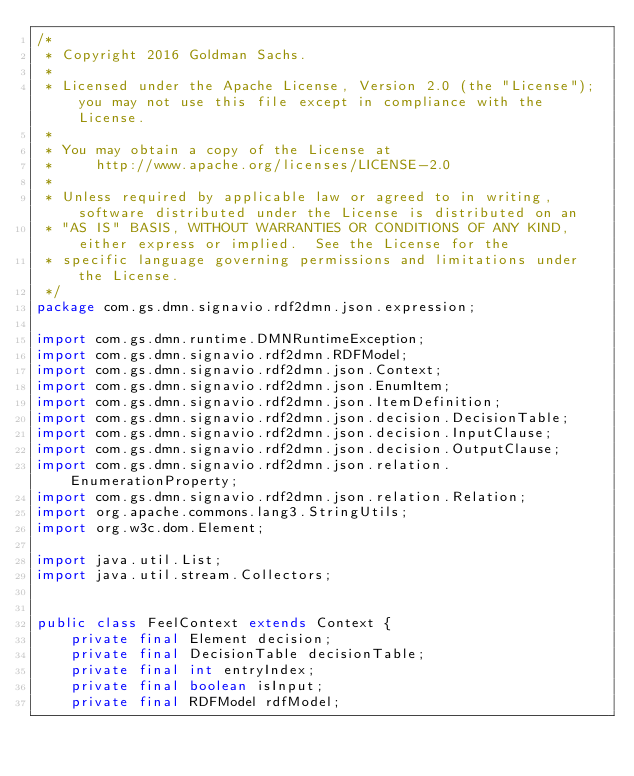Convert code to text. <code><loc_0><loc_0><loc_500><loc_500><_Java_>/*
 * Copyright 2016 Goldman Sachs.
 *
 * Licensed under the Apache License, Version 2.0 (the "License"); you may not use this file except in compliance with the License.
 *
 * You may obtain a copy of the License at
 *     http://www.apache.org/licenses/LICENSE-2.0
 *
 * Unless required by applicable law or agreed to in writing, software distributed under the License is distributed on an
 * "AS IS" BASIS, WITHOUT WARRANTIES OR CONDITIONS OF ANY KIND, either express or implied.  See the License for the
 * specific language governing permissions and limitations under the License.
 */
package com.gs.dmn.signavio.rdf2dmn.json.expression;

import com.gs.dmn.runtime.DMNRuntimeException;
import com.gs.dmn.signavio.rdf2dmn.RDFModel;
import com.gs.dmn.signavio.rdf2dmn.json.Context;
import com.gs.dmn.signavio.rdf2dmn.json.EnumItem;
import com.gs.dmn.signavio.rdf2dmn.json.ItemDefinition;
import com.gs.dmn.signavio.rdf2dmn.json.decision.DecisionTable;
import com.gs.dmn.signavio.rdf2dmn.json.decision.InputClause;
import com.gs.dmn.signavio.rdf2dmn.json.decision.OutputClause;
import com.gs.dmn.signavio.rdf2dmn.json.relation.EnumerationProperty;
import com.gs.dmn.signavio.rdf2dmn.json.relation.Relation;
import org.apache.commons.lang3.StringUtils;
import org.w3c.dom.Element;

import java.util.List;
import java.util.stream.Collectors;


public class FeelContext extends Context {
    private final Element decision;
    private final DecisionTable decisionTable;
    private final int entryIndex;
    private final boolean isInput;
    private final RDFModel rdfModel;
</code> 